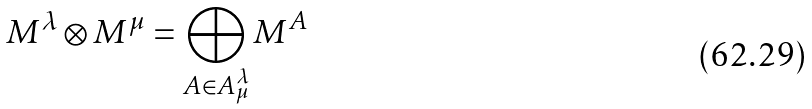Convert formula to latex. <formula><loc_0><loc_0><loc_500><loc_500>M ^ { \lambda } \otimes M ^ { \mu } = \bigoplus _ { A \in A ^ { \lambda } _ { \mu } } M ^ { A }</formula> 